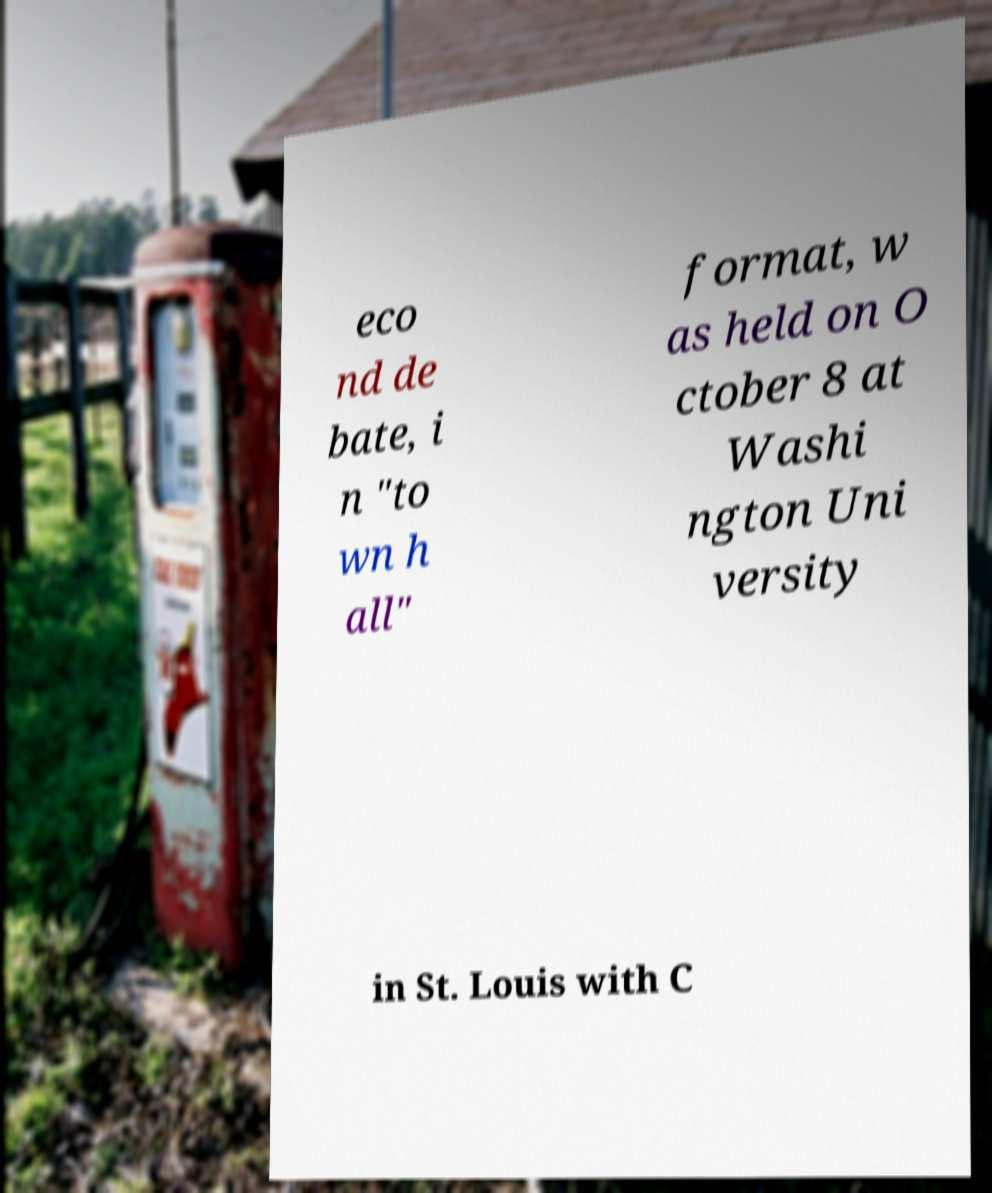Can you accurately transcribe the text from the provided image for me? eco nd de bate, i n "to wn h all" format, w as held on O ctober 8 at Washi ngton Uni versity in St. Louis with C 